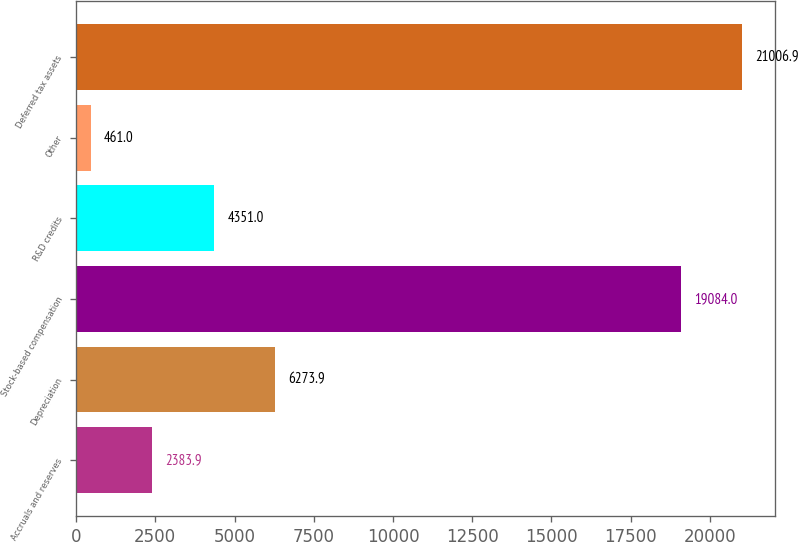Convert chart. <chart><loc_0><loc_0><loc_500><loc_500><bar_chart><fcel>Accruals and reserves<fcel>Depreciation<fcel>Stock-based compensation<fcel>R&D credits<fcel>Other<fcel>Deferred tax assets<nl><fcel>2383.9<fcel>6273.9<fcel>19084<fcel>4351<fcel>461<fcel>21006.9<nl></chart> 